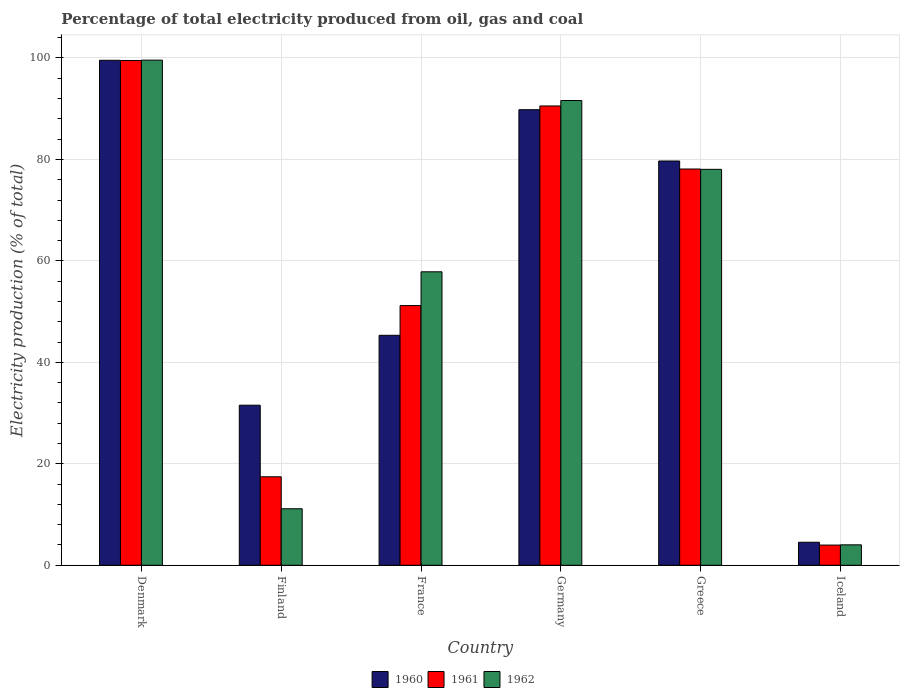How many different coloured bars are there?
Offer a terse response. 3. What is the label of the 4th group of bars from the left?
Provide a succinct answer. Germany. In how many cases, is the number of bars for a given country not equal to the number of legend labels?
Ensure brevity in your answer.  0. What is the electricity production in in 1962 in Iceland?
Provide a succinct answer. 4.03. Across all countries, what is the maximum electricity production in in 1962?
Ensure brevity in your answer.  99.58. Across all countries, what is the minimum electricity production in in 1960?
Offer a very short reply. 4.54. In which country was the electricity production in in 1961 maximum?
Ensure brevity in your answer.  Denmark. In which country was the electricity production in in 1961 minimum?
Keep it short and to the point. Iceland. What is the total electricity production in in 1962 in the graph?
Provide a succinct answer. 342.26. What is the difference between the electricity production in in 1961 in Denmark and that in France?
Offer a terse response. 48.32. What is the difference between the electricity production in in 1961 in Finland and the electricity production in in 1962 in Germany?
Offer a terse response. -74.18. What is the average electricity production in in 1960 per country?
Offer a very short reply. 58.41. What is the difference between the electricity production in of/in 1961 and electricity production in of/in 1962 in Iceland?
Provide a succinct answer. -0.05. What is the ratio of the electricity production in in 1962 in Finland to that in Iceland?
Give a very brief answer. 2.77. Is the electricity production in in 1962 in Finland less than that in Germany?
Offer a terse response. Yes. What is the difference between the highest and the second highest electricity production in in 1961?
Your answer should be very brief. -8.97. What is the difference between the highest and the lowest electricity production in in 1962?
Give a very brief answer. 95.55. In how many countries, is the electricity production in in 1961 greater than the average electricity production in in 1961 taken over all countries?
Offer a terse response. 3. Is the sum of the electricity production in in 1960 in Denmark and Germany greater than the maximum electricity production in in 1961 across all countries?
Offer a very short reply. Yes. Is it the case that in every country, the sum of the electricity production in in 1960 and electricity production in in 1961 is greater than the electricity production in in 1962?
Your answer should be compact. Yes. How many bars are there?
Offer a terse response. 18. Are all the bars in the graph horizontal?
Ensure brevity in your answer.  No. What is the difference between two consecutive major ticks on the Y-axis?
Your answer should be compact. 20. Are the values on the major ticks of Y-axis written in scientific E-notation?
Offer a very short reply. No. Does the graph contain grids?
Keep it short and to the point. Yes. How many legend labels are there?
Make the answer very short. 3. How are the legend labels stacked?
Give a very brief answer. Horizontal. What is the title of the graph?
Give a very brief answer. Percentage of total electricity produced from oil, gas and coal. What is the label or title of the X-axis?
Ensure brevity in your answer.  Country. What is the label or title of the Y-axis?
Offer a terse response. Electricity production (% of total). What is the Electricity production (% of total) in 1960 in Denmark?
Provide a short and direct response. 99.55. What is the Electricity production (% of total) of 1961 in Denmark?
Ensure brevity in your answer.  99.51. What is the Electricity production (% of total) of 1962 in Denmark?
Provide a succinct answer. 99.58. What is the Electricity production (% of total) in 1960 in Finland?
Your answer should be very brief. 31.55. What is the Electricity production (% of total) of 1961 in Finland?
Give a very brief answer. 17.44. What is the Electricity production (% of total) of 1962 in Finland?
Provide a succinct answer. 11.14. What is the Electricity production (% of total) in 1960 in France?
Provide a succinct answer. 45.33. What is the Electricity production (% of total) of 1961 in France?
Give a very brief answer. 51.19. What is the Electricity production (% of total) of 1962 in France?
Make the answer very short. 57.85. What is the Electricity production (% of total) of 1960 in Germany?
Provide a succinct answer. 89.81. What is the Electricity production (% of total) in 1961 in Germany?
Make the answer very short. 90.54. What is the Electricity production (% of total) in 1962 in Germany?
Your answer should be compact. 91.62. What is the Electricity production (% of total) in 1960 in Greece?
Ensure brevity in your answer.  79.69. What is the Electricity production (% of total) in 1961 in Greece?
Provide a succinct answer. 78.12. What is the Electricity production (% of total) in 1962 in Greece?
Offer a terse response. 78.05. What is the Electricity production (% of total) in 1960 in Iceland?
Offer a very short reply. 4.54. What is the Electricity production (% of total) in 1961 in Iceland?
Ensure brevity in your answer.  3.98. What is the Electricity production (% of total) in 1962 in Iceland?
Offer a terse response. 4.03. Across all countries, what is the maximum Electricity production (% of total) of 1960?
Make the answer very short. 99.55. Across all countries, what is the maximum Electricity production (% of total) of 1961?
Provide a short and direct response. 99.51. Across all countries, what is the maximum Electricity production (% of total) in 1962?
Your response must be concise. 99.58. Across all countries, what is the minimum Electricity production (% of total) in 1960?
Offer a terse response. 4.54. Across all countries, what is the minimum Electricity production (% of total) of 1961?
Your answer should be compact. 3.98. Across all countries, what is the minimum Electricity production (% of total) in 1962?
Your response must be concise. 4.03. What is the total Electricity production (% of total) in 1960 in the graph?
Make the answer very short. 350.47. What is the total Electricity production (% of total) of 1961 in the graph?
Keep it short and to the point. 340.79. What is the total Electricity production (% of total) of 1962 in the graph?
Provide a short and direct response. 342.26. What is the difference between the Electricity production (% of total) of 1960 in Denmark and that in Finland?
Give a very brief answer. 68. What is the difference between the Electricity production (% of total) of 1961 in Denmark and that in Finland?
Provide a succinct answer. 82.07. What is the difference between the Electricity production (% of total) of 1962 in Denmark and that in Finland?
Offer a terse response. 88.44. What is the difference between the Electricity production (% of total) of 1960 in Denmark and that in France?
Keep it short and to the point. 54.22. What is the difference between the Electricity production (% of total) in 1961 in Denmark and that in France?
Provide a succinct answer. 48.32. What is the difference between the Electricity production (% of total) of 1962 in Denmark and that in France?
Provide a short and direct response. 41.73. What is the difference between the Electricity production (% of total) in 1960 in Denmark and that in Germany?
Offer a terse response. 9.74. What is the difference between the Electricity production (% of total) in 1961 in Denmark and that in Germany?
Your response must be concise. 8.97. What is the difference between the Electricity production (% of total) in 1962 in Denmark and that in Germany?
Your response must be concise. 7.96. What is the difference between the Electricity production (% of total) in 1960 in Denmark and that in Greece?
Your answer should be very brief. 19.85. What is the difference between the Electricity production (% of total) of 1961 in Denmark and that in Greece?
Provide a succinct answer. 21.39. What is the difference between the Electricity production (% of total) of 1962 in Denmark and that in Greece?
Your answer should be very brief. 21.53. What is the difference between the Electricity production (% of total) of 1960 in Denmark and that in Iceland?
Provide a short and direct response. 95.01. What is the difference between the Electricity production (% of total) in 1961 in Denmark and that in Iceland?
Ensure brevity in your answer.  95.53. What is the difference between the Electricity production (% of total) in 1962 in Denmark and that in Iceland?
Your answer should be compact. 95.55. What is the difference between the Electricity production (% of total) of 1960 in Finland and that in France?
Provide a succinct answer. -13.78. What is the difference between the Electricity production (% of total) of 1961 in Finland and that in France?
Make the answer very short. -33.75. What is the difference between the Electricity production (% of total) of 1962 in Finland and that in France?
Provide a short and direct response. -46.71. What is the difference between the Electricity production (% of total) in 1960 in Finland and that in Germany?
Make the answer very short. -58.26. What is the difference between the Electricity production (% of total) in 1961 in Finland and that in Germany?
Keep it short and to the point. -73.1. What is the difference between the Electricity production (% of total) of 1962 in Finland and that in Germany?
Offer a very short reply. -80.48. What is the difference between the Electricity production (% of total) in 1960 in Finland and that in Greece?
Offer a very short reply. -48.14. What is the difference between the Electricity production (% of total) of 1961 in Finland and that in Greece?
Your response must be concise. -60.68. What is the difference between the Electricity production (% of total) of 1962 in Finland and that in Greece?
Your answer should be very brief. -66.91. What is the difference between the Electricity production (% of total) in 1960 in Finland and that in Iceland?
Your answer should be compact. 27.01. What is the difference between the Electricity production (% of total) of 1961 in Finland and that in Iceland?
Your answer should be very brief. 13.46. What is the difference between the Electricity production (% of total) in 1962 in Finland and that in Iceland?
Provide a succinct answer. 7.11. What is the difference between the Electricity production (% of total) of 1960 in France and that in Germany?
Ensure brevity in your answer.  -44.48. What is the difference between the Electricity production (% of total) in 1961 in France and that in Germany?
Your response must be concise. -39.35. What is the difference between the Electricity production (% of total) in 1962 in France and that in Germany?
Your answer should be very brief. -33.77. What is the difference between the Electricity production (% of total) in 1960 in France and that in Greece?
Your answer should be very brief. -34.36. What is the difference between the Electricity production (% of total) in 1961 in France and that in Greece?
Your answer should be very brief. -26.92. What is the difference between the Electricity production (% of total) in 1962 in France and that in Greece?
Provide a succinct answer. -20.2. What is the difference between the Electricity production (% of total) in 1960 in France and that in Iceland?
Keep it short and to the point. 40.8. What is the difference between the Electricity production (% of total) in 1961 in France and that in Iceland?
Your answer should be very brief. 47.21. What is the difference between the Electricity production (% of total) in 1962 in France and that in Iceland?
Make the answer very short. 53.83. What is the difference between the Electricity production (% of total) in 1960 in Germany and that in Greece?
Offer a very short reply. 10.11. What is the difference between the Electricity production (% of total) of 1961 in Germany and that in Greece?
Ensure brevity in your answer.  12.43. What is the difference between the Electricity production (% of total) of 1962 in Germany and that in Greece?
Provide a short and direct response. 13.57. What is the difference between the Electricity production (% of total) in 1960 in Germany and that in Iceland?
Your response must be concise. 85.27. What is the difference between the Electricity production (% of total) in 1961 in Germany and that in Iceland?
Provide a succinct answer. 86.56. What is the difference between the Electricity production (% of total) of 1962 in Germany and that in Iceland?
Provide a succinct answer. 87.59. What is the difference between the Electricity production (% of total) in 1960 in Greece and that in Iceland?
Provide a succinct answer. 75.16. What is the difference between the Electricity production (% of total) of 1961 in Greece and that in Iceland?
Provide a short and direct response. 74.14. What is the difference between the Electricity production (% of total) in 1962 in Greece and that in Iceland?
Provide a short and direct response. 74.02. What is the difference between the Electricity production (% of total) of 1960 in Denmark and the Electricity production (% of total) of 1961 in Finland?
Provide a short and direct response. 82.11. What is the difference between the Electricity production (% of total) of 1960 in Denmark and the Electricity production (% of total) of 1962 in Finland?
Make the answer very short. 88.41. What is the difference between the Electricity production (% of total) of 1961 in Denmark and the Electricity production (% of total) of 1962 in Finland?
Keep it short and to the point. 88.37. What is the difference between the Electricity production (% of total) in 1960 in Denmark and the Electricity production (% of total) in 1961 in France?
Make the answer very short. 48.36. What is the difference between the Electricity production (% of total) in 1960 in Denmark and the Electricity production (% of total) in 1962 in France?
Make the answer very short. 41.7. What is the difference between the Electricity production (% of total) in 1961 in Denmark and the Electricity production (% of total) in 1962 in France?
Give a very brief answer. 41.66. What is the difference between the Electricity production (% of total) of 1960 in Denmark and the Electricity production (% of total) of 1961 in Germany?
Offer a very short reply. 9. What is the difference between the Electricity production (% of total) in 1960 in Denmark and the Electricity production (% of total) in 1962 in Germany?
Provide a short and direct response. 7.93. What is the difference between the Electricity production (% of total) of 1961 in Denmark and the Electricity production (% of total) of 1962 in Germany?
Your answer should be compact. 7.89. What is the difference between the Electricity production (% of total) of 1960 in Denmark and the Electricity production (% of total) of 1961 in Greece?
Your response must be concise. 21.43. What is the difference between the Electricity production (% of total) in 1960 in Denmark and the Electricity production (% of total) in 1962 in Greece?
Keep it short and to the point. 21.5. What is the difference between the Electricity production (% of total) of 1961 in Denmark and the Electricity production (% of total) of 1962 in Greece?
Keep it short and to the point. 21.46. What is the difference between the Electricity production (% of total) of 1960 in Denmark and the Electricity production (% of total) of 1961 in Iceland?
Offer a very short reply. 95.57. What is the difference between the Electricity production (% of total) of 1960 in Denmark and the Electricity production (% of total) of 1962 in Iceland?
Offer a terse response. 95.52. What is the difference between the Electricity production (% of total) in 1961 in Denmark and the Electricity production (% of total) in 1962 in Iceland?
Keep it short and to the point. 95.49. What is the difference between the Electricity production (% of total) of 1960 in Finland and the Electricity production (% of total) of 1961 in France?
Keep it short and to the point. -19.64. What is the difference between the Electricity production (% of total) in 1960 in Finland and the Electricity production (% of total) in 1962 in France?
Offer a very short reply. -26.3. What is the difference between the Electricity production (% of total) in 1961 in Finland and the Electricity production (% of total) in 1962 in France?
Make the answer very short. -40.41. What is the difference between the Electricity production (% of total) of 1960 in Finland and the Electricity production (% of total) of 1961 in Germany?
Make the answer very short. -58.99. What is the difference between the Electricity production (% of total) in 1960 in Finland and the Electricity production (% of total) in 1962 in Germany?
Provide a succinct answer. -60.07. What is the difference between the Electricity production (% of total) in 1961 in Finland and the Electricity production (% of total) in 1962 in Germany?
Offer a very short reply. -74.18. What is the difference between the Electricity production (% of total) of 1960 in Finland and the Electricity production (% of total) of 1961 in Greece?
Keep it short and to the point. -46.57. What is the difference between the Electricity production (% of total) in 1960 in Finland and the Electricity production (% of total) in 1962 in Greece?
Offer a very short reply. -46.5. What is the difference between the Electricity production (% of total) in 1961 in Finland and the Electricity production (% of total) in 1962 in Greece?
Your answer should be very brief. -60.61. What is the difference between the Electricity production (% of total) in 1960 in Finland and the Electricity production (% of total) in 1961 in Iceland?
Ensure brevity in your answer.  27.57. What is the difference between the Electricity production (% of total) in 1960 in Finland and the Electricity production (% of total) in 1962 in Iceland?
Provide a short and direct response. 27.53. What is the difference between the Electricity production (% of total) of 1961 in Finland and the Electricity production (% of total) of 1962 in Iceland?
Your answer should be compact. 13.41. What is the difference between the Electricity production (% of total) of 1960 in France and the Electricity production (% of total) of 1961 in Germany?
Your response must be concise. -45.21. What is the difference between the Electricity production (% of total) in 1960 in France and the Electricity production (% of total) in 1962 in Germany?
Your answer should be very brief. -46.29. What is the difference between the Electricity production (% of total) of 1961 in France and the Electricity production (% of total) of 1962 in Germany?
Offer a very short reply. -40.43. What is the difference between the Electricity production (% of total) of 1960 in France and the Electricity production (% of total) of 1961 in Greece?
Ensure brevity in your answer.  -32.78. What is the difference between the Electricity production (% of total) in 1960 in France and the Electricity production (% of total) in 1962 in Greece?
Give a very brief answer. -32.72. What is the difference between the Electricity production (% of total) of 1961 in France and the Electricity production (% of total) of 1962 in Greece?
Provide a short and direct response. -26.86. What is the difference between the Electricity production (% of total) in 1960 in France and the Electricity production (% of total) in 1961 in Iceland?
Make the answer very short. 41.35. What is the difference between the Electricity production (% of total) in 1960 in France and the Electricity production (% of total) in 1962 in Iceland?
Keep it short and to the point. 41.31. What is the difference between the Electricity production (% of total) in 1961 in France and the Electricity production (% of total) in 1962 in Iceland?
Give a very brief answer. 47.17. What is the difference between the Electricity production (% of total) of 1960 in Germany and the Electricity production (% of total) of 1961 in Greece?
Make the answer very short. 11.69. What is the difference between the Electricity production (% of total) of 1960 in Germany and the Electricity production (% of total) of 1962 in Greece?
Your response must be concise. 11.76. What is the difference between the Electricity production (% of total) in 1961 in Germany and the Electricity production (% of total) in 1962 in Greece?
Your response must be concise. 12.49. What is the difference between the Electricity production (% of total) in 1960 in Germany and the Electricity production (% of total) in 1961 in Iceland?
Provide a succinct answer. 85.83. What is the difference between the Electricity production (% of total) of 1960 in Germany and the Electricity production (% of total) of 1962 in Iceland?
Your answer should be very brief. 85.78. What is the difference between the Electricity production (% of total) of 1961 in Germany and the Electricity production (% of total) of 1962 in Iceland?
Ensure brevity in your answer.  86.52. What is the difference between the Electricity production (% of total) of 1960 in Greece and the Electricity production (% of total) of 1961 in Iceland?
Your answer should be very brief. 75.71. What is the difference between the Electricity production (% of total) of 1960 in Greece and the Electricity production (% of total) of 1962 in Iceland?
Give a very brief answer. 75.67. What is the difference between the Electricity production (% of total) of 1961 in Greece and the Electricity production (% of total) of 1962 in Iceland?
Provide a succinct answer. 74.09. What is the average Electricity production (% of total) of 1960 per country?
Provide a succinct answer. 58.41. What is the average Electricity production (% of total) in 1961 per country?
Offer a terse response. 56.8. What is the average Electricity production (% of total) in 1962 per country?
Ensure brevity in your answer.  57.04. What is the difference between the Electricity production (% of total) in 1960 and Electricity production (% of total) in 1961 in Denmark?
Provide a succinct answer. 0.04. What is the difference between the Electricity production (% of total) of 1960 and Electricity production (% of total) of 1962 in Denmark?
Provide a succinct answer. -0.03. What is the difference between the Electricity production (% of total) in 1961 and Electricity production (% of total) in 1962 in Denmark?
Ensure brevity in your answer.  -0.07. What is the difference between the Electricity production (% of total) in 1960 and Electricity production (% of total) in 1961 in Finland?
Ensure brevity in your answer.  14.11. What is the difference between the Electricity production (% of total) in 1960 and Electricity production (% of total) in 1962 in Finland?
Ensure brevity in your answer.  20.41. What is the difference between the Electricity production (% of total) of 1961 and Electricity production (% of total) of 1962 in Finland?
Offer a very short reply. 6.3. What is the difference between the Electricity production (% of total) in 1960 and Electricity production (% of total) in 1961 in France?
Your answer should be very brief. -5.86. What is the difference between the Electricity production (% of total) in 1960 and Electricity production (% of total) in 1962 in France?
Provide a succinct answer. -12.52. What is the difference between the Electricity production (% of total) in 1961 and Electricity production (% of total) in 1962 in France?
Offer a very short reply. -6.66. What is the difference between the Electricity production (% of total) of 1960 and Electricity production (% of total) of 1961 in Germany?
Your answer should be compact. -0.74. What is the difference between the Electricity production (% of total) in 1960 and Electricity production (% of total) in 1962 in Germany?
Provide a short and direct response. -1.81. What is the difference between the Electricity production (% of total) in 1961 and Electricity production (% of total) in 1962 in Germany?
Ensure brevity in your answer.  -1.07. What is the difference between the Electricity production (% of total) in 1960 and Electricity production (% of total) in 1961 in Greece?
Provide a succinct answer. 1.58. What is the difference between the Electricity production (% of total) of 1960 and Electricity production (% of total) of 1962 in Greece?
Offer a terse response. 1.64. What is the difference between the Electricity production (% of total) of 1961 and Electricity production (% of total) of 1962 in Greece?
Make the answer very short. 0.07. What is the difference between the Electricity production (% of total) of 1960 and Electricity production (% of total) of 1961 in Iceland?
Make the answer very short. 0.56. What is the difference between the Electricity production (% of total) in 1960 and Electricity production (% of total) in 1962 in Iceland?
Your response must be concise. 0.51. What is the difference between the Electricity production (% of total) in 1961 and Electricity production (% of total) in 1962 in Iceland?
Provide a short and direct response. -0.05. What is the ratio of the Electricity production (% of total) in 1960 in Denmark to that in Finland?
Keep it short and to the point. 3.16. What is the ratio of the Electricity production (% of total) in 1961 in Denmark to that in Finland?
Your answer should be very brief. 5.71. What is the ratio of the Electricity production (% of total) in 1962 in Denmark to that in Finland?
Your answer should be very brief. 8.94. What is the ratio of the Electricity production (% of total) of 1960 in Denmark to that in France?
Give a very brief answer. 2.2. What is the ratio of the Electricity production (% of total) in 1961 in Denmark to that in France?
Your response must be concise. 1.94. What is the ratio of the Electricity production (% of total) in 1962 in Denmark to that in France?
Your answer should be very brief. 1.72. What is the ratio of the Electricity production (% of total) in 1960 in Denmark to that in Germany?
Your answer should be very brief. 1.11. What is the ratio of the Electricity production (% of total) in 1961 in Denmark to that in Germany?
Provide a succinct answer. 1.1. What is the ratio of the Electricity production (% of total) of 1962 in Denmark to that in Germany?
Ensure brevity in your answer.  1.09. What is the ratio of the Electricity production (% of total) in 1960 in Denmark to that in Greece?
Give a very brief answer. 1.25. What is the ratio of the Electricity production (% of total) of 1961 in Denmark to that in Greece?
Offer a terse response. 1.27. What is the ratio of the Electricity production (% of total) of 1962 in Denmark to that in Greece?
Make the answer very short. 1.28. What is the ratio of the Electricity production (% of total) in 1960 in Denmark to that in Iceland?
Your answer should be compact. 21.94. What is the ratio of the Electricity production (% of total) of 1961 in Denmark to that in Iceland?
Keep it short and to the point. 25. What is the ratio of the Electricity production (% of total) in 1962 in Denmark to that in Iceland?
Ensure brevity in your answer.  24.74. What is the ratio of the Electricity production (% of total) in 1960 in Finland to that in France?
Offer a very short reply. 0.7. What is the ratio of the Electricity production (% of total) of 1961 in Finland to that in France?
Provide a succinct answer. 0.34. What is the ratio of the Electricity production (% of total) in 1962 in Finland to that in France?
Offer a very short reply. 0.19. What is the ratio of the Electricity production (% of total) of 1960 in Finland to that in Germany?
Your answer should be compact. 0.35. What is the ratio of the Electricity production (% of total) in 1961 in Finland to that in Germany?
Ensure brevity in your answer.  0.19. What is the ratio of the Electricity production (% of total) in 1962 in Finland to that in Germany?
Make the answer very short. 0.12. What is the ratio of the Electricity production (% of total) of 1960 in Finland to that in Greece?
Your answer should be compact. 0.4. What is the ratio of the Electricity production (% of total) in 1961 in Finland to that in Greece?
Your answer should be very brief. 0.22. What is the ratio of the Electricity production (% of total) in 1962 in Finland to that in Greece?
Provide a short and direct response. 0.14. What is the ratio of the Electricity production (% of total) of 1960 in Finland to that in Iceland?
Provide a short and direct response. 6.95. What is the ratio of the Electricity production (% of total) in 1961 in Finland to that in Iceland?
Your response must be concise. 4.38. What is the ratio of the Electricity production (% of total) of 1962 in Finland to that in Iceland?
Offer a very short reply. 2.77. What is the ratio of the Electricity production (% of total) in 1960 in France to that in Germany?
Keep it short and to the point. 0.5. What is the ratio of the Electricity production (% of total) in 1961 in France to that in Germany?
Your answer should be very brief. 0.57. What is the ratio of the Electricity production (% of total) of 1962 in France to that in Germany?
Provide a succinct answer. 0.63. What is the ratio of the Electricity production (% of total) in 1960 in France to that in Greece?
Provide a short and direct response. 0.57. What is the ratio of the Electricity production (% of total) of 1961 in France to that in Greece?
Provide a succinct answer. 0.66. What is the ratio of the Electricity production (% of total) in 1962 in France to that in Greece?
Make the answer very short. 0.74. What is the ratio of the Electricity production (% of total) in 1960 in France to that in Iceland?
Keep it short and to the point. 9.99. What is the ratio of the Electricity production (% of total) of 1961 in France to that in Iceland?
Keep it short and to the point. 12.86. What is the ratio of the Electricity production (% of total) in 1962 in France to that in Iceland?
Ensure brevity in your answer.  14.37. What is the ratio of the Electricity production (% of total) in 1960 in Germany to that in Greece?
Ensure brevity in your answer.  1.13. What is the ratio of the Electricity production (% of total) in 1961 in Germany to that in Greece?
Give a very brief answer. 1.16. What is the ratio of the Electricity production (% of total) in 1962 in Germany to that in Greece?
Give a very brief answer. 1.17. What is the ratio of the Electricity production (% of total) of 1960 in Germany to that in Iceland?
Give a very brief answer. 19.79. What is the ratio of the Electricity production (% of total) of 1961 in Germany to that in Iceland?
Your answer should be compact. 22.75. What is the ratio of the Electricity production (% of total) in 1962 in Germany to that in Iceland?
Your answer should be very brief. 22.76. What is the ratio of the Electricity production (% of total) of 1960 in Greece to that in Iceland?
Provide a short and direct response. 17.56. What is the ratio of the Electricity production (% of total) of 1961 in Greece to that in Iceland?
Your answer should be compact. 19.63. What is the ratio of the Electricity production (% of total) of 1962 in Greece to that in Iceland?
Keep it short and to the point. 19.39. What is the difference between the highest and the second highest Electricity production (% of total) of 1960?
Provide a succinct answer. 9.74. What is the difference between the highest and the second highest Electricity production (% of total) of 1961?
Ensure brevity in your answer.  8.97. What is the difference between the highest and the second highest Electricity production (% of total) of 1962?
Make the answer very short. 7.96. What is the difference between the highest and the lowest Electricity production (% of total) of 1960?
Give a very brief answer. 95.01. What is the difference between the highest and the lowest Electricity production (% of total) of 1961?
Offer a very short reply. 95.53. What is the difference between the highest and the lowest Electricity production (% of total) in 1962?
Keep it short and to the point. 95.55. 